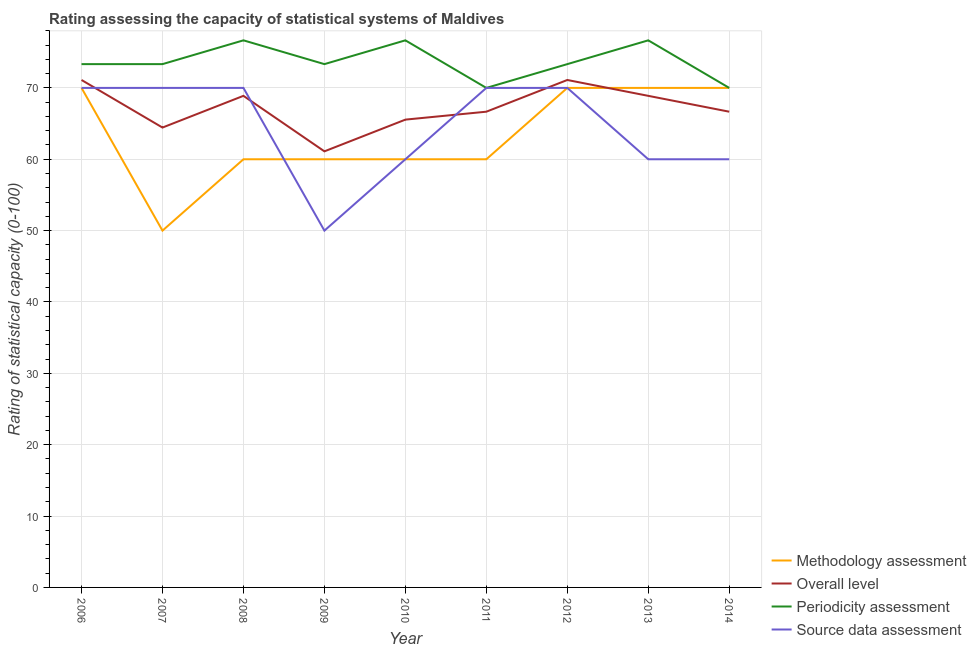How many different coloured lines are there?
Your response must be concise. 4. Is the number of lines equal to the number of legend labels?
Make the answer very short. Yes. Across all years, what is the maximum source data assessment rating?
Your response must be concise. 70. Across all years, what is the minimum overall level rating?
Your response must be concise. 61.11. In which year was the methodology assessment rating maximum?
Provide a succinct answer. 2006. What is the total source data assessment rating in the graph?
Offer a very short reply. 580. What is the difference between the periodicity assessment rating in 2009 and that in 2014?
Provide a succinct answer. 3.33. What is the average periodicity assessment rating per year?
Make the answer very short. 73.7. In the year 2009, what is the difference between the overall level rating and methodology assessment rating?
Offer a very short reply. 1.11. In how many years, is the overall level rating greater than 8?
Your response must be concise. 9. What is the ratio of the source data assessment rating in 2007 to that in 2011?
Keep it short and to the point. 1. Is the source data assessment rating in 2011 less than that in 2013?
Keep it short and to the point. No. Is the difference between the methodology assessment rating in 2006 and 2012 greater than the difference between the source data assessment rating in 2006 and 2012?
Offer a terse response. No. What is the difference between the highest and the second highest overall level rating?
Give a very brief answer. 0. What is the difference between the highest and the lowest periodicity assessment rating?
Offer a very short reply. 6.67. Is it the case that in every year, the sum of the methodology assessment rating and source data assessment rating is greater than the sum of periodicity assessment rating and overall level rating?
Give a very brief answer. No. Is it the case that in every year, the sum of the methodology assessment rating and overall level rating is greater than the periodicity assessment rating?
Ensure brevity in your answer.  Yes. Does the overall level rating monotonically increase over the years?
Your response must be concise. No. Is the overall level rating strictly less than the periodicity assessment rating over the years?
Give a very brief answer. Yes. How many years are there in the graph?
Your response must be concise. 9. What is the difference between two consecutive major ticks on the Y-axis?
Offer a terse response. 10. Does the graph contain any zero values?
Your answer should be compact. No. Does the graph contain grids?
Your response must be concise. Yes. Where does the legend appear in the graph?
Keep it short and to the point. Bottom right. How many legend labels are there?
Offer a very short reply. 4. How are the legend labels stacked?
Keep it short and to the point. Vertical. What is the title of the graph?
Provide a succinct answer. Rating assessing the capacity of statistical systems of Maldives. Does "International Development Association" appear as one of the legend labels in the graph?
Offer a very short reply. No. What is the label or title of the Y-axis?
Your answer should be compact. Rating of statistical capacity (0-100). What is the Rating of statistical capacity (0-100) of Methodology assessment in 2006?
Your response must be concise. 70. What is the Rating of statistical capacity (0-100) in Overall level in 2006?
Offer a very short reply. 71.11. What is the Rating of statistical capacity (0-100) of Periodicity assessment in 2006?
Offer a very short reply. 73.33. What is the Rating of statistical capacity (0-100) in Source data assessment in 2006?
Your answer should be very brief. 70. What is the Rating of statistical capacity (0-100) in Overall level in 2007?
Your answer should be very brief. 64.44. What is the Rating of statistical capacity (0-100) in Periodicity assessment in 2007?
Ensure brevity in your answer.  73.33. What is the Rating of statistical capacity (0-100) of Overall level in 2008?
Make the answer very short. 68.89. What is the Rating of statistical capacity (0-100) of Periodicity assessment in 2008?
Provide a short and direct response. 76.67. What is the Rating of statistical capacity (0-100) in Source data assessment in 2008?
Offer a very short reply. 70. What is the Rating of statistical capacity (0-100) of Overall level in 2009?
Provide a short and direct response. 61.11. What is the Rating of statistical capacity (0-100) in Periodicity assessment in 2009?
Your answer should be very brief. 73.33. What is the Rating of statistical capacity (0-100) in Methodology assessment in 2010?
Offer a very short reply. 60. What is the Rating of statistical capacity (0-100) of Overall level in 2010?
Keep it short and to the point. 65.56. What is the Rating of statistical capacity (0-100) of Periodicity assessment in 2010?
Offer a terse response. 76.67. What is the Rating of statistical capacity (0-100) in Source data assessment in 2010?
Your response must be concise. 60. What is the Rating of statistical capacity (0-100) of Overall level in 2011?
Keep it short and to the point. 66.67. What is the Rating of statistical capacity (0-100) of Source data assessment in 2011?
Your answer should be compact. 70. What is the Rating of statistical capacity (0-100) of Overall level in 2012?
Provide a succinct answer. 71.11. What is the Rating of statistical capacity (0-100) of Periodicity assessment in 2012?
Give a very brief answer. 73.33. What is the Rating of statistical capacity (0-100) in Source data assessment in 2012?
Your response must be concise. 70. What is the Rating of statistical capacity (0-100) of Overall level in 2013?
Provide a succinct answer. 68.89. What is the Rating of statistical capacity (0-100) in Periodicity assessment in 2013?
Provide a short and direct response. 76.67. What is the Rating of statistical capacity (0-100) in Methodology assessment in 2014?
Provide a succinct answer. 70. What is the Rating of statistical capacity (0-100) of Overall level in 2014?
Offer a very short reply. 66.67. What is the Rating of statistical capacity (0-100) in Periodicity assessment in 2014?
Your response must be concise. 70. Across all years, what is the maximum Rating of statistical capacity (0-100) of Methodology assessment?
Offer a very short reply. 70. Across all years, what is the maximum Rating of statistical capacity (0-100) in Overall level?
Offer a terse response. 71.11. Across all years, what is the maximum Rating of statistical capacity (0-100) of Periodicity assessment?
Keep it short and to the point. 76.67. Across all years, what is the maximum Rating of statistical capacity (0-100) of Source data assessment?
Provide a short and direct response. 70. Across all years, what is the minimum Rating of statistical capacity (0-100) in Overall level?
Provide a succinct answer. 61.11. What is the total Rating of statistical capacity (0-100) of Methodology assessment in the graph?
Provide a short and direct response. 570. What is the total Rating of statistical capacity (0-100) in Overall level in the graph?
Make the answer very short. 604.44. What is the total Rating of statistical capacity (0-100) of Periodicity assessment in the graph?
Make the answer very short. 663.33. What is the total Rating of statistical capacity (0-100) in Source data assessment in the graph?
Make the answer very short. 580. What is the difference between the Rating of statistical capacity (0-100) of Methodology assessment in 2006 and that in 2007?
Provide a succinct answer. 20. What is the difference between the Rating of statistical capacity (0-100) of Overall level in 2006 and that in 2007?
Give a very brief answer. 6.67. What is the difference between the Rating of statistical capacity (0-100) in Periodicity assessment in 2006 and that in 2007?
Your answer should be very brief. 0. What is the difference between the Rating of statistical capacity (0-100) of Methodology assessment in 2006 and that in 2008?
Your response must be concise. 10. What is the difference between the Rating of statistical capacity (0-100) of Overall level in 2006 and that in 2008?
Your answer should be very brief. 2.22. What is the difference between the Rating of statistical capacity (0-100) of Periodicity assessment in 2006 and that in 2008?
Offer a terse response. -3.33. What is the difference between the Rating of statistical capacity (0-100) in Source data assessment in 2006 and that in 2009?
Ensure brevity in your answer.  20. What is the difference between the Rating of statistical capacity (0-100) in Methodology assessment in 2006 and that in 2010?
Offer a very short reply. 10. What is the difference between the Rating of statistical capacity (0-100) in Overall level in 2006 and that in 2010?
Offer a very short reply. 5.56. What is the difference between the Rating of statistical capacity (0-100) of Periodicity assessment in 2006 and that in 2010?
Provide a short and direct response. -3.33. What is the difference between the Rating of statistical capacity (0-100) of Source data assessment in 2006 and that in 2010?
Make the answer very short. 10. What is the difference between the Rating of statistical capacity (0-100) of Overall level in 2006 and that in 2011?
Your answer should be very brief. 4.44. What is the difference between the Rating of statistical capacity (0-100) of Periodicity assessment in 2006 and that in 2011?
Offer a terse response. 3.33. What is the difference between the Rating of statistical capacity (0-100) in Source data assessment in 2006 and that in 2011?
Make the answer very short. 0. What is the difference between the Rating of statistical capacity (0-100) of Methodology assessment in 2006 and that in 2012?
Offer a terse response. 0. What is the difference between the Rating of statistical capacity (0-100) of Overall level in 2006 and that in 2012?
Your answer should be compact. 0. What is the difference between the Rating of statistical capacity (0-100) in Periodicity assessment in 2006 and that in 2012?
Provide a succinct answer. 0. What is the difference between the Rating of statistical capacity (0-100) of Methodology assessment in 2006 and that in 2013?
Offer a very short reply. 0. What is the difference between the Rating of statistical capacity (0-100) of Overall level in 2006 and that in 2013?
Provide a succinct answer. 2.22. What is the difference between the Rating of statistical capacity (0-100) in Overall level in 2006 and that in 2014?
Ensure brevity in your answer.  4.44. What is the difference between the Rating of statistical capacity (0-100) in Source data assessment in 2006 and that in 2014?
Offer a very short reply. 10. What is the difference between the Rating of statistical capacity (0-100) of Methodology assessment in 2007 and that in 2008?
Offer a terse response. -10. What is the difference between the Rating of statistical capacity (0-100) in Overall level in 2007 and that in 2008?
Offer a very short reply. -4.44. What is the difference between the Rating of statistical capacity (0-100) in Overall level in 2007 and that in 2009?
Your answer should be compact. 3.33. What is the difference between the Rating of statistical capacity (0-100) of Source data assessment in 2007 and that in 2009?
Offer a terse response. 20. What is the difference between the Rating of statistical capacity (0-100) of Overall level in 2007 and that in 2010?
Offer a terse response. -1.11. What is the difference between the Rating of statistical capacity (0-100) in Periodicity assessment in 2007 and that in 2010?
Make the answer very short. -3.33. What is the difference between the Rating of statistical capacity (0-100) in Overall level in 2007 and that in 2011?
Provide a succinct answer. -2.22. What is the difference between the Rating of statistical capacity (0-100) in Periodicity assessment in 2007 and that in 2011?
Make the answer very short. 3.33. What is the difference between the Rating of statistical capacity (0-100) in Overall level in 2007 and that in 2012?
Offer a very short reply. -6.67. What is the difference between the Rating of statistical capacity (0-100) in Methodology assessment in 2007 and that in 2013?
Make the answer very short. -20. What is the difference between the Rating of statistical capacity (0-100) in Overall level in 2007 and that in 2013?
Give a very brief answer. -4.44. What is the difference between the Rating of statistical capacity (0-100) in Periodicity assessment in 2007 and that in 2013?
Ensure brevity in your answer.  -3.33. What is the difference between the Rating of statistical capacity (0-100) in Overall level in 2007 and that in 2014?
Your answer should be very brief. -2.22. What is the difference between the Rating of statistical capacity (0-100) in Periodicity assessment in 2007 and that in 2014?
Provide a short and direct response. 3.33. What is the difference between the Rating of statistical capacity (0-100) in Overall level in 2008 and that in 2009?
Offer a terse response. 7.78. What is the difference between the Rating of statistical capacity (0-100) of Periodicity assessment in 2008 and that in 2009?
Provide a succinct answer. 3.33. What is the difference between the Rating of statistical capacity (0-100) of Source data assessment in 2008 and that in 2009?
Offer a terse response. 20. What is the difference between the Rating of statistical capacity (0-100) in Overall level in 2008 and that in 2010?
Offer a terse response. 3.33. What is the difference between the Rating of statistical capacity (0-100) in Methodology assessment in 2008 and that in 2011?
Your answer should be very brief. 0. What is the difference between the Rating of statistical capacity (0-100) of Overall level in 2008 and that in 2011?
Your answer should be compact. 2.22. What is the difference between the Rating of statistical capacity (0-100) in Periodicity assessment in 2008 and that in 2011?
Keep it short and to the point. 6.67. What is the difference between the Rating of statistical capacity (0-100) of Source data assessment in 2008 and that in 2011?
Provide a short and direct response. 0. What is the difference between the Rating of statistical capacity (0-100) in Overall level in 2008 and that in 2012?
Offer a terse response. -2.22. What is the difference between the Rating of statistical capacity (0-100) of Periodicity assessment in 2008 and that in 2012?
Provide a succinct answer. 3.33. What is the difference between the Rating of statistical capacity (0-100) in Methodology assessment in 2008 and that in 2013?
Offer a terse response. -10. What is the difference between the Rating of statistical capacity (0-100) in Source data assessment in 2008 and that in 2013?
Your response must be concise. 10. What is the difference between the Rating of statistical capacity (0-100) of Overall level in 2008 and that in 2014?
Offer a terse response. 2.22. What is the difference between the Rating of statistical capacity (0-100) in Source data assessment in 2008 and that in 2014?
Your answer should be very brief. 10. What is the difference between the Rating of statistical capacity (0-100) of Methodology assessment in 2009 and that in 2010?
Keep it short and to the point. 0. What is the difference between the Rating of statistical capacity (0-100) of Overall level in 2009 and that in 2010?
Provide a succinct answer. -4.44. What is the difference between the Rating of statistical capacity (0-100) in Source data assessment in 2009 and that in 2010?
Your answer should be very brief. -10. What is the difference between the Rating of statistical capacity (0-100) of Overall level in 2009 and that in 2011?
Offer a very short reply. -5.56. What is the difference between the Rating of statistical capacity (0-100) in Periodicity assessment in 2009 and that in 2011?
Your answer should be compact. 3.33. What is the difference between the Rating of statistical capacity (0-100) in Source data assessment in 2009 and that in 2011?
Offer a terse response. -20. What is the difference between the Rating of statistical capacity (0-100) in Methodology assessment in 2009 and that in 2012?
Ensure brevity in your answer.  -10. What is the difference between the Rating of statistical capacity (0-100) of Overall level in 2009 and that in 2012?
Provide a short and direct response. -10. What is the difference between the Rating of statistical capacity (0-100) in Source data assessment in 2009 and that in 2012?
Make the answer very short. -20. What is the difference between the Rating of statistical capacity (0-100) in Methodology assessment in 2009 and that in 2013?
Your answer should be compact. -10. What is the difference between the Rating of statistical capacity (0-100) in Overall level in 2009 and that in 2013?
Ensure brevity in your answer.  -7.78. What is the difference between the Rating of statistical capacity (0-100) in Periodicity assessment in 2009 and that in 2013?
Your response must be concise. -3.33. What is the difference between the Rating of statistical capacity (0-100) of Methodology assessment in 2009 and that in 2014?
Your response must be concise. -10. What is the difference between the Rating of statistical capacity (0-100) in Overall level in 2009 and that in 2014?
Your response must be concise. -5.56. What is the difference between the Rating of statistical capacity (0-100) in Periodicity assessment in 2009 and that in 2014?
Offer a very short reply. 3.33. What is the difference between the Rating of statistical capacity (0-100) of Source data assessment in 2009 and that in 2014?
Provide a short and direct response. -10. What is the difference between the Rating of statistical capacity (0-100) of Methodology assessment in 2010 and that in 2011?
Your response must be concise. 0. What is the difference between the Rating of statistical capacity (0-100) of Overall level in 2010 and that in 2011?
Make the answer very short. -1.11. What is the difference between the Rating of statistical capacity (0-100) in Overall level in 2010 and that in 2012?
Offer a terse response. -5.56. What is the difference between the Rating of statistical capacity (0-100) of Methodology assessment in 2010 and that in 2013?
Offer a very short reply. -10. What is the difference between the Rating of statistical capacity (0-100) of Overall level in 2010 and that in 2014?
Provide a short and direct response. -1.11. What is the difference between the Rating of statistical capacity (0-100) of Periodicity assessment in 2010 and that in 2014?
Provide a short and direct response. 6.67. What is the difference between the Rating of statistical capacity (0-100) of Methodology assessment in 2011 and that in 2012?
Make the answer very short. -10. What is the difference between the Rating of statistical capacity (0-100) of Overall level in 2011 and that in 2012?
Make the answer very short. -4.44. What is the difference between the Rating of statistical capacity (0-100) of Periodicity assessment in 2011 and that in 2012?
Give a very brief answer. -3.33. What is the difference between the Rating of statistical capacity (0-100) of Overall level in 2011 and that in 2013?
Offer a very short reply. -2.22. What is the difference between the Rating of statistical capacity (0-100) in Periodicity assessment in 2011 and that in 2013?
Provide a short and direct response. -6.67. What is the difference between the Rating of statistical capacity (0-100) in Overall level in 2011 and that in 2014?
Your response must be concise. 0. What is the difference between the Rating of statistical capacity (0-100) in Source data assessment in 2011 and that in 2014?
Offer a terse response. 10. What is the difference between the Rating of statistical capacity (0-100) of Overall level in 2012 and that in 2013?
Your response must be concise. 2.22. What is the difference between the Rating of statistical capacity (0-100) in Periodicity assessment in 2012 and that in 2013?
Keep it short and to the point. -3.33. What is the difference between the Rating of statistical capacity (0-100) of Overall level in 2012 and that in 2014?
Keep it short and to the point. 4.44. What is the difference between the Rating of statistical capacity (0-100) of Periodicity assessment in 2012 and that in 2014?
Offer a terse response. 3.33. What is the difference between the Rating of statistical capacity (0-100) of Methodology assessment in 2013 and that in 2014?
Give a very brief answer. 0. What is the difference between the Rating of statistical capacity (0-100) of Overall level in 2013 and that in 2014?
Keep it short and to the point. 2.22. What is the difference between the Rating of statistical capacity (0-100) in Periodicity assessment in 2013 and that in 2014?
Your answer should be compact. 6.67. What is the difference between the Rating of statistical capacity (0-100) of Source data assessment in 2013 and that in 2014?
Your answer should be compact. 0. What is the difference between the Rating of statistical capacity (0-100) of Methodology assessment in 2006 and the Rating of statistical capacity (0-100) of Overall level in 2007?
Offer a very short reply. 5.56. What is the difference between the Rating of statistical capacity (0-100) in Overall level in 2006 and the Rating of statistical capacity (0-100) in Periodicity assessment in 2007?
Offer a terse response. -2.22. What is the difference between the Rating of statistical capacity (0-100) in Periodicity assessment in 2006 and the Rating of statistical capacity (0-100) in Source data assessment in 2007?
Keep it short and to the point. 3.33. What is the difference between the Rating of statistical capacity (0-100) in Methodology assessment in 2006 and the Rating of statistical capacity (0-100) in Periodicity assessment in 2008?
Provide a succinct answer. -6.67. What is the difference between the Rating of statistical capacity (0-100) in Methodology assessment in 2006 and the Rating of statistical capacity (0-100) in Source data assessment in 2008?
Ensure brevity in your answer.  0. What is the difference between the Rating of statistical capacity (0-100) in Overall level in 2006 and the Rating of statistical capacity (0-100) in Periodicity assessment in 2008?
Give a very brief answer. -5.56. What is the difference between the Rating of statistical capacity (0-100) in Methodology assessment in 2006 and the Rating of statistical capacity (0-100) in Overall level in 2009?
Provide a short and direct response. 8.89. What is the difference between the Rating of statistical capacity (0-100) of Methodology assessment in 2006 and the Rating of statistical capacity (0-100) of Periodicity assessment in 2009?
Provide a short and direct response. -3.33. What is the difference between the Rating of statistical capacity (0-100) of Overall level in 2006 and the Rating of statistical capacity (0-100) of Periodicity assessment in 2009?
Your response must be concise. -2.22. What is the difference between the Rating of statistical capacity (0-100) in Overall level in 2006 and the Rating of statistical capacity (0-100) in Source data assessment in 2009?
Keep it short and to the point. 21.11. What is the difference between the Rating of statistical capacity (0-100) in Periodicity assessment in 2006 and the Rating of statistical capacity (0-100) in Source data assessment in 2009?
Ensure brevity in your answer.  23.33. What is the difference between the Rating of statistical capacity (0-100) in Methodology assessment in 2006 and the Rating of statistical capacity (0-100) in Overall level in 2010?
Give a very brief answer. 4.44. What is the difference between the Rating of statistical capacity (0-100) in Methodology assessment in 2006 and the Rating of statistical capacity (0-100) in Periodicity assessment in 2010?
Offer a terse response. -6.67. What is the difference between the Rating of statistical capacity (0-100) of Overall level in 2006 and the Rating of statistical capacity (0-100) of Periodicity assessment in 2010?
Your answer should be very brief. -5.56. What is the difference between the Rating of statistical capacity (0-100) of Overall level in 2006 and the Rating of statistical capacity (0-100) of Source data assessment in 2010?
Your answer should be very brief. 11.11. What is the difference between the Rating of statistical capacity (0-100) in Periodicity assessment in 2006 and the Rating of statistical capacity (0-100) in Source data assessment in 2010?
Provide a short and direct response. 13.33. What is the difference between the Rating of statistical capacity (0-100) of Methodology assessment in 2006 and the Rating of statistical capacity (0-100) of Periodicity assessment in 2011?
Offer a terse response. 0. What is the difference between the Rating of statistical capacity (0-100) in Methodology assessment in 2006 and the Rating of statistical capacity (0-100) in Source data assessment in 2011?
Your answer should be compact. 0. What is the difference between the Rating of statistical capacity (0-100) of Overall level in 2006 and the Rating of statistical capacity (0-100) of Periodicity assessment in 2011?
Your response must be concise. 1.11. What is the difference between the Rating of statistical capacity (0-100) in Methodology assessment in 2006 and the Rating of statistical capacity (0-100) in Overall level in 2012?
Offer a very short reply. -1.11. What is the difference between the Rating of statistical capacity (0-100) of Methodology assessment in 2006 and the Rating of statistical capacity (0-100) of Periodicity assessment in 2012?
Ensure brevity in your answer.  -3.33. What is the difference between the Rating of statistical capacity (0-100) in Overall level in 2006 and the Rating of statistical capacity (0-100) in Periodicity assessment in 2012?
Keep it short and to the point. -2.22. What is the difference between the Rating of statistical capacity (0-100) in Periodicity assessment in 2006 and the Rating of statistical capacity (0-100) in Source data assessment in 2012?
Keep it short and to the point. 3.33. What is the difference between the Rating of statistical capacity (0-100) of Methodology assessment in 2006 and the Rating of statistical capacity (0-100) of Overall level in 2013?
Provide a succinct answer. 1.11. What is the difference between the Rating of statistical capacity (0-100) of Methodology assessment in 2006 and the Rating of statistical capacity (0-100) of Periodicity assessment in 2013?
Give a very brief answer. -6.67. What is the difference between the Rating of statistical capacity (0-100) of Overall level in 2006 and the Rating of statistical capacity (0-100) of Periodicity assessment in 2013?
Ensure brevity in your answer.  -5.56. What is the difference between the Rating of statistical capacity (0-100) of Overall level in 2006 and the Rating of statistical capacity (0-100) of Source data assessment in 2013?
Offer a terse response. 11.11. What is the difference between the Rating of statistical capacity (0-100) in Periodicity assessment in 2006 and the Rating of statistical capacity (0-100) in Source data assessment in 2013?
Give a very brief answer. 13.33. What is the difference between the Rating of statistical capacity (0-100) of Methodology assessment in 2006 and the Rating of statistical capacity (0-100) of Overall level in 2014?
Ensure brevity in your answer.  3.33. What is the difference between the Rating of statistical capacity (0-100) in Methodology assessment in 2006 and the Rating of statistical capacity (0-100) in Periodicity assessment in 2014?
Offer a terse response. 0. What is the difference between the Rating of statistical capacity (0-100) of Methodology assessment in 2006 and the Rating of statistical capacity (0-100) of Source data assessment in 2014?
Your response must be concise. 10. What is the difference between the Rating of statistical capacity (0-100) in Overall level in 2006 and the Rating of statistical capacity (0-100) in Source data assessment in 2014?
Your response must be concise. 11.11. What is the difference between the Rating of statistical capacity (0-100) of Periodicity assessment in 2006 and the Rating of statistical capacity (0-100) of Source data assessment in 2014?
Make the answer very short. 13.33. What is the difference between the Rating of statistical capacity (0-100) of Methodology assessment in 2007 and the Rating of statistical capacity (0-100) of Overall level in 2008?
Ensure brevity in your answer.  -18.89. What is the difference between the Rating of statistical capacity (0-100) in Methodology assessment in 2007 and the Rating of statistical capacity (0-100) in Periodicity assessment in 2008?
Offer a very short reply. -26.67. What is the difference between the Rating of statistical capacity (0-100) of Methodology assessment in 2007 and the Rating of statistical capacity (0-100) of Source data assessment in 2008?
Provide a succinct answer. -20. What is the difference between the Rating of statistical capacity (0-100) in Overall level in 2007 and the Rating of statistical capacity (0-100) in Periodicity assessment in 2008?
Offer a very short reply. -12.22. What is the difference between the Rating of statistical capacity (0-100) in Overall level in 2007 and the Rating of statistical capacity (0-100) in Source data assessment in 2008?
Give a very brief answer. -5.56. What is the difference between the Rating of statistical capacity (0-100) in Methodology assessment in 2007 and the Rating of statistical capacity (0-100) in Overall level in 2009?
Your response must be concise. -11.11. What is the difference between the Rating of statistical capacity (0-100) in Methodology assessment in 2007 and the Rating of statistical capacity (0-100) in Periodicity assessment in 2009?
Offer a terse response. -23.33. What is the difference between the Rating of statistical capacity (0-100) of Overall level in 2007 and the Rating of statistical capacity (0-100) of Periodicity assessment in 2009?
Your answer should be compact. -8.89. What is the difference between the Rating of statistical capacity (0-100) in Overall level in 2007 and the Rating of statistical capacity (0-100) in Source data assessment in 2009?
Your answer should be very brief. 14.44. What is the difference between the Rating of statistical capacity (0-100) of Periodicity assessment in 2007 and the Rating of statistical capacity (0-100) of Source data assessment in 2009?
Your response must be concise. 23.33. What is the difference between the Rating of statistical capacity (0-100) of Methodology assessment in 2007 and the Rating of statistical capacity (0-100) of Overall level in 2010?
Your response must be concise. -15.56. What is the difference between the Rating of statistical capacity (0-100) of Methodology assessment in 2007 and the Rating of statistical capacity (0-100) of Periodicity assessment in 2010?
Make the answer very short. -26.67. What is the difference between the Rating of statistical capacity (0-100) in Overall level in 2007 and the Rating of statistical capacity (0-100) in Periodicity assessment in 2010?
Offer a very short reply. -12.22. What is the difference between the Rating of statistical capacity (0-100) in Overall level in 2007 and the Rating of statistical capacity (0-100) in Source data assessment in 2010?
Offer a terse response. 4.44. What is the difference between the Rating of statistical capacity (0-100) in Periodicity assessment in 2007 and the Rating of statistical capacity (0-100) in Source data assessment in 2010?
Ensure brevity in your answer.  13.33. What is the difference between the Rating of statistical capacity (0-100) in Methodology assessment in 2007 and the Rating of statistical capacity (0-100) in Overall level in 2011?
Your answer should be compact. -16.67. What is the difference between the Rating of statistical capacity (0-100) in Methodology assessment in 2007 and the Rating of statistical capacity (0-100) in Periodicity assessment in 2011?
Ensure brevity in your answer.  -20. What is the difference between the Rating of statistical capacity (0-100) in Overall level in 2007 and the Rating of statistical capacity (0-100) in Periodicity assessment in 2011?
Give a very brief answer. -5.56. What is the difference between the Rating of statistical capacity (0-100) of Overall level in 2007 and the Rating of statistical capacity (0-100) of Source data assessment in 2011?
Make the answer very short. -5.56. What is the difference between the Rating of statistical capacity (0-100) in Periodicity assessment in 2007 and the Rating of statistical capacity (0-100) in Source data assessment in 2011?
Keep it short and to the point. 3.33. What is the difference between the Rating of statistical capacity (0-100) of Methodology assessment in 2007 and the Rating of statistical capacity (0-100) of Overall level in 2012?
Give a very brief answer. -21.11. What is the difference between the Rating of statistical capacity (0-100) of Methodology assessment in 2007 and the Rating of statistical capacity (0-100) of Periodicity assessment in 2012?
Provide a succinct answer. -23.33. What is the difference between the Rating of statistical capacity (0-100) in Overall level in 2007 and the Rating of statistical capacity (0-100) in Periodicity assessment in 2012?
Keep it short and to the point. -8.89. What is the difference between the Rating of statistical capacity (0-100) in Overall level in 2007 and the Rating of statistical capacity (0-100) in Source data assessment in 2012?
Offer a terse response. -5.56. What is the difference between the Rating of statistical capacity (0-100) in Methodology assessment in 2007 and the Rating of statistical capacity (0-100) in Overall level in 2013?
Make the answer very short. -18.89. What is the difference between the Rating of statistical capacity (0-100) of Methodology assessment in 2007 and the Rating of statistical capacity (0-100) of Periodicity assessment in 2013?
Provide a succinct answer. -26.67. What is the difference between the Rating of statistical capacity (0-100) in Overall level in 2007 and the Rating of statistical capacity (0-100) in Periodicity assessment in 2013?
Your answer should be very brief. -12.22. What is the difference between the Rating of statistical capacity (0-100) of Overall level in 2007 and the Rating of statistical capacity (0-100) of Source data assessment in 2013?
Your answer should be compact. 4.44. What is the difference between the Rating of statistical capacity (0-100) of Periodicity assessment in 2007 and the Rating of statistical capacity (0-100) of Source data assessment in 2013?
Ensure brevity in your answer.  13.33. What is the difference between the Rating of statistical capacity (0-100) of Methodology assessment in 2007 and the Rating of statistical capacity (0-100) of Overall level in 2014?
Make the answer very short. -16.67. What is the difference between the Rating of statistical capacity (0-100) in Methodology assessment in 2007 and the Rating of statistical capacity (0-100) in Source data assessment in 2014?
Give a very brief answer. -10. What is the difference between the Rating of statistical capacity (0-100) in Overall level in 2007 and the Rating of statistical capacity (0-100) in Periodicity assessment in 2014?
Your answer should be very brief. -5.56. What is the difference between the Rating of statistical capacity (0-100) of Overall level in 2007 and the Rating of statistical capacity (0-100) of Source data assessment in 2014?
Offer a very short reply. 4.44. What is the difference between the Rating of statistical capacity (0-100) in Periodicity assessment in 2007 and the Rating of statistical capacity (0-100) in Source data assessment in 2014?
Make the answer very short. 13.33. What is the difference between the Rating of statistical capacity (0-100) of Methodology assessment in 2008 and the Rating of statistical capacity (0-100) of Overall level in 2009?
Provide a short and direct response. -1.11. What is the difference between the Rating of statistical capacity (0-100) in Methodology assessment in 2008 and the Rating of statistical capacity (0-100) in Periodicity assessment in 2009?
Give a very brief answer. -13.33. What is the difference between the Rating of statistical capacity (0-100) in Overall level in 2008 and the Rating of statistical capacity (0-100) in Periodicity assessment in 2009?
Give a very brief answer. -4.44. What is the difference between the Rating of statistical capacity (0-100) in Overall level in 2008 and the Rating of statistical capacity (0-100) in Source data assessment in 2009?
Offer a terse response. 18.89. What is the difference between the Rating of statistical capacity (0-100) in Periodicity assessment in 2008 and the Rating of statistical capacity (0-100) in Source data assessment in 2009?
Provide a short and direct response. 26.67. What is the difference between the Rating of statistical capacity (0-100) in Methodology assessment in 2008 and the Rating of statistical capacity (0-100) in Overall level in 2010?
Give a very brief answer. -5.56. What is the difference between the Rating of statistical capacity (0-100) of Methodology assessment in 2008 and the Rating of statistical capacity (0-100) of Periodicity assessment in 2010?
Keep it short and to the point. -16.67. What is the difference between the Rating of statistical capacity (0-100) in Methodology assessment in 2008 and the Rating of statistical capacity (0-100) in Source data assessment in 2010?
Give a very brief answer. 0. What is the difference between the Rating of statistical capacity (0-100) of Overall level in 2008 and the Rating of statistical capacity (0-100) of Periodicity assessment in 2010?
Your answer should be compact. -7.78. What is the difference between the Rating of statistical capacity (0-100) in Overall level in 2008 and the Rating of statistical capacity (0-100) in Source data assessment in 2010?
Ensure brevity in your answer.  8.89. What is the difference between the Rating of statistical capacity (0-100) in Periodicity assessment in 2008 and the Rating of statistical capacity (0-100) in Source data assessment in 2010?
Keep it short and to the point. 16.67. What is the difference between the Rating of statistical capacity (0-100) in Methodology assessment in 2008 and the Rating of statistical capacity (0-100) in Overall level in 2011?
Offer a terse response. -6.67. What is the difference between the Rating of statistical capacity (0-100) in Methodology assessment in 2008 and the Rating of statistical capacity (0-100) in Source data assessment in 2011?
Offer a very short reply. -10. What is the difference between the Rating of statistical capacity (0-100) of Overall level in 2008 and the Rating of statistical capacity (0-100) of Periodicity assessment in 2011?
Offer a very short reply. -1.11. What is the difference between the Rating of statistical capacity (0-100) of Overall level in 2008 and the Rating of statistical capacity (0-100) of Source data assessment in 2011?
Your response must be concise. -1.11. What is the difference between the Rating of statistical capacity (0-100) of Methodology assessment in 2008 and the Rating of statistical capacity (0-100) of Overall level in 2012?
Make the answer very short. -11.11. What is the difference between the Rating of statistical capacity (0-100) of Methodology assessment in 2008 and the Rating of statistical capacity (0-100) of Periodicity assessment in 2012?
Provide a short and direct response. -13.33. What is the difference between the Rating of statistical capacity (0-100) of Methodology assessment in 2008 and the Rating of statistical capacity (0-100) of Source data assessment in 2012?
Offer a terse response. -10. What is the difference between the Rating of statistical capacity (0-100) of Overall level in 2008 and the Rating of statistical capacity (0-100) of Periodicity assessment in 2012?
Provide a succinct answer. -4.44. What is the difference between the Rating of statistical capacity (0-100) of Overall level in 2008 and the Rating of statistical capacity (0-100) of Source data assessment in 2012?
Your answer should be very brief. -1.11. What is the difference between the Rating of statistical capacity (0-100) in Periodicity assessment in 2008 and the Rating of statistical capacity (0-100) in Source data assessment in 2012?
Provide a short and direct response. 6.67. What is the difference between the Rating of statistical capacity (0-100) in Methodology assessment in 2008 and the Rating of statistical capacity (0-100) in Overall level in 2013?
Ensure brevity in your answer.  -8.89. What is the difference between the Rating of statistical capacity (0-100) of Methodology assessment in 2008 and the Rating of statistical capacity (0-100) of Periodicity assessment in 2013?
Your response must be concise. -16.67. What is the difference between the Rating of statistical capacity (0-100) of Methodology assessment in 2008 and the Rating of statistical capacity (0-100) of Source data assessment in 2013?
Your answer should be very brief. 0. What is the difference between the Rating of statistical capacity (0-100) in Overall level in 2008 and the Rating of statistical capacity (0-100) in Periodicity assessment in 2013?
Ensure brevity in your answer.  -7.78. What is the difference between the Rating of statistical capacity (0-100) of Overall level in 2008 and the Rating of statistical capacity (0-100) of Source data assessment in 2013?
Your answer should be very brief. 8.89. What is the difference between the Rating of statistical capacity (0-100) in Periodicity assessment in 2008 and the Rating of statistical capacity (0-100) in Source data assessment in 2013?
Make the answer very short. 16.67. What is the difference between the Rating of statistical capacity (0-100) of Methodology assessment in 2008 and the Rating of statistical capacity (0-100) of Overall level in 2014?
Ensure brevity in your answer.  -6.67. What is the difference between the Rating of statistical capacity (0-100) in Overall level in 2008 and the Rating of statistical capacity (0-100) in Periodicity assessment in 2014?
Offer a very short reply. -1.11. What is the difference between the Rating of statistical capacity (0-100) of Overall level in 2008 and the Rating of statistical capacity (0-100) of Source data assessment in 2014?
Ensure brevity in your answer.  8.89. What is the difference between the Rating of statistical capacity (0-100) of Periodicity assessment in 2008 and the Rating of statistical capacity (0-100) of Source data assessment in 2014?
Your response must be concise. 16.67. What is the difference between the Rating of statistical capacity (0-100) of Methodology assessment in 2009 and the Rating of statistical capacity (0-100) of Overall level in 2010?
Give a very brief answer. -5.56. What is the difference between the Rating of statistical capacity (0-100) of Methodology assessment in 2009 and the Rating of statistical capacity (0-100) of Periodicity assessment in 2010?
Offer a very short reply. -16.67. What is the difference between the Rating of statistical capacity (0-100) in Overall level in 2009 and the Rating of statistical capacity (0-100) in Periodicity assessment in 2010?
Provide a short and direct response. -15.56. What is the difference between the Rating of statistical capacity (0-100) of Overall level in 2009 and the Rating of statistical capacity (0-100) of Source data assessment in 2010?
Your answer should be compact. 1.11. What is the difference between the Rating of statistical capacity (0-100) in Periodicity assessment in 2009 and the Rating of statistical capacity (0-100) in Source data assessment in 2010?
Keep it short and to the point. 13.33. What is the difference between the Rating of statistical capacity (0-100) of Methodology assessment in 2009 and the Rating of statistical capacity (0-100) of Overall level in 2011?
Keep it short and to the point. -6.67. What is the difference between the Rating of statistical capacity (0-100) of Methodology assessment in 2009 and the Rating of statistical capacity (0-100) of Periodicity assessment in 2011?
Provide a succinct answer. -10. What is the difference between the Rating of statistical capacity (0-100) of Overall level in 2009 and the Rating of statistical capacity (0-100) of Periodicity assessment in 2011?
Provide a short and direct response. -8.89. What is the difference between the Rating of statistical capacity (0-100) of Overall level in 2009 and the Rating of statistical capacity (0-100) of Source data assessment in 2011?
Offer a very short reply. -8.89. What is the difference between the Rating of statistical capacity (0-100) of Periodicity assessment in 2009 and the Rating of statistical capacity (0-100) of Source data assessment in 2011?
Your response must be concise. 3.33. What is the difference between the Rating of statistical capacity (0-100) in Methodology assessment in 2009 and the Rating of statistical capacity (0-100) in Overall level in 2012?
Provide a succinct answer. -11.11. What is the difference between the Rating of statistical capacity (0-100) in Methodology assessment in 2009 and the Rating of statistical capacity (0-100) in Periodicity assessment in 2012?
Your answer should be very brief. -13.33. What is the difference between the Rating of statistical capacity (0-100) in Overall level in 2009 and the Rating of statistical capacity (0-100) in Periodicity assessment in 2012?
Your answer should be very brief. -12.22. What is the difference between the Rating of statistical capacity (0-100) in Overall level in 2009 and the Rating of statistical capacity (0-100) in Source data assessment in 2012?
Your response must be concise. -8.89. What is the difference between the Rating of statistical capacity (0-100) of Methodology assessment in 2009 and the Rating of statistical capacity (0-100) of Overall level in 2013?
Your answer should be compact. -8.89. What is the difference between the Rating of statistical capacity (0-100) of Methodology assessment in 2009 and the Rating of statistical capacity (0-100) of Periodicity assessment in 2013?
Provide a succinct answer. -16.67. What is the difference between the Rating of statistical capacity (0-100) in Overall level in 2009 and the Rating of statistical capacity (0-100) in Periodicity assessment in 2013?
Provide a succinct answer. -15.56. What is the difference between the Rating of statistical capacity (0-100) in Periodicity assessment in 2009 and the Rating of statistical capacity (0-100) in Source data assessment in 2013?
Your response must be concise. 13.33. What is the difference between the Rating of statistical capacity (0-100) in Methodology assessment in 2009 and the Rating of statistical capacity (0-100) in Overall level in 2014?
Offer a terse response. -6.67. What is the difference between the Rating of statistical capacity (0-100) in Methodology assessment in 2009 and the Rating of statistical capacity (0-100) in Periodicity assessment in 2014?
Make the answer very short. -10. What is the difference between the Rating of statistical capacity (0-100) of Methodology assessment in 2009 and the Rating of statistical capacity (0-100) of Source data assessment in 2014?
Your answer should be very brief. 0. What is the difference between the Rating of statistical capacity (0-100) in Overall level in 2009 and the Rating of statistical capacity (0-100) in Periodicity assessment in 2014?
Offer a terse response. -8.89. What is the difference between the Rating of statistical capacity (0-100) of Periodicity assessment in 2009 and the Rating of statistical capacity (0-100) of Source data assessment in 2014?
Offer a very short reply. 13.33. What is the difference between the Rating of statistical capacity (0-100) of Methodology assessment in 2010 and the Rating of statistical capacity (0-100) of Overall level in 2011?
Give a very brief answer. -6.67. What is the difference between the Rating of statistical capacity (0-100) in Methodology assessment in 2010 and the Rating of statistical capacity (0-100) in Periodicity assessment in 2011?
Offer a very short reply. -10. What is the difference between the Rating of statistical capacity (0-100) in Methodology assessment in 2010 and the Rating of statistical capacity (0-100) in Source data assessment in 2011?
Give a very brief answer. -10. What is the difference between the Rating of statistical capacity (0-100) of Overall level in 2010 and the Rating of statistical capacity (0-100) of Periodicity assessment in 2011?
Give a very brief answer. -4.44. What is the difference between the Rating of statistical capacity (0-100) of Overall level in 2010 and the Rating of statistical capacity (0-100) of Source data assessment in 2011?
Ensure brevity in your answer.  -4.44. What is the difference between the Rating of statistical capacity (0-100) of Periodicity assessment in 2010 and the Rating of statistical capacity (0-100) of Source data assessment in 2011?
Your answer should be very brief. 6.67. What is the difference between the Rating of statistical capacity (0-100) in Methodology assessment in 2010 and the Rating of statistical capacity (0-100) in Overall level in 2012?
Make the answer very short. -11.11. What is the difference between the Rating of statistical capacity (0-100) in Methodology assessment in 2010 and the Rating of statistical capacity (0-100) in Periodicity assessment in 2012?
Ensure brevity in your answer.  -13.33. What is the difference between the Rating of statistical capacity (0-100) of Overall level in 2010 and the Rating of statistical capacity (0-100) of Periodicity assessment in 2012?
Your answer should be very brief. -7.78. What is the difference between the Rating of statistical capacity (0-100) of Overall level in 2010 and the Rating of statistical capacity (0-100) of Source data assessment in 2012?
Ensure brevity in your answer.  -4.44. What is the difference between the Rating of statistical capacity (0-100) in Methodology assessment in 2010 and the Rating of statistical capacity (0-100) in Overall level in 2013?
Keep it short and to the point. -8.89. What is the difference between the Rating of statistical capacity (0-100) in Methodology assessment in 2010 and the Rating of statistical capacity (0-100) in Periodicity assessment in 2013?
Provide a succinct answer. -16.67. What is the difference between the Rating of statistical capacity (0-100) in Methodology assessment in 2010 and the Rating of statistical capacity (0-100) in Source data assessment in 2013?
Your answer should be compact. 0. What is the difference between the Rating of statistical capacity (0-100) in Overall level in 2010 and the Rating of statistical capacity (0-100) in Periodicity assessment in 2013?
Make the answer very short. -11.11. What is the difference between the Rating of statistical capacity (0-100) of Overall level in 2010 and the Rating of statistical capacity (0-100) of Source data assessment in 2013?
Offer a terse response. 5.56. What is the difference between the Rating of statistical capacity (0-100) in Periodicity assessment in 2010 and the Rating of statistical capacity (0-100) in Source data assessment in 2013?
Keep it short and to the point. 16.67. What is the difference between the Rating of statistical capacity (0-100) of Methodology assessment in 2010 and the Rating of statistical capacity (0-100) of Overall level in 2014?
Your answer should be very brief. -6.67. What is the difference between the Rating of statistical capacity (0-100) of Methodology assessment in 2010 and the Rating of statistical capacity (0-100) of Periodicity assessment in 2014?
Offer a terse response. -10. What is the difference between the Rating of statistical capacity (0-100) of Overall level in 2010 and the Rating of statistical capacity (0-100) of Periodicity assessment in 2014?
Give a very brief answer. -4.44. What is the difference between the Rating of statistical capacity (0-100) of Overall level in 2010 and the Rating of statistical capacity (0-100) of Source data assessment in 2014?
Provide a succinct answer. 5.56. What is the difference between the Rating of statistical capacity (0-100) of Periodicity assessment in 2010 and the Rating of statistical capacity (0-100) of Source data assessment in 2014?
Make the answer very short. 16.67. What is the difference between the Rating of statistical capacity (0-100) of Methodology assessment in 2011 and the Rating of statistical capacity (0-100) of Overall level in 2012?
Offer a very short reply. -11.11. What is the difference between the Rating of statistical capacity (0-100) in Methodology assessment in 2011 and the Rating of statistical capacity (0-100) in Periodicity assessment in 2012?
Offer a terse response. -13.33. What is the difference between the Rating of statistical capacity (0-100) in Methodology assessment in 2011 and the Rating of statistical capacity (0-100) in Source data assessment in 2012?
Provide a short and direct response. -10. What is the difference between the Rating of statistical capacity (0-100) of Overall level in 2011 and the Rating of statistical capacity (0-100) of Periodicity assessment in 2012?
Provide a succinct answer. -6.67. What is the difference between the Rating of statistical capacity (0-100) in Overall level in 2011 and the Rating of statistical capacity (0-100) in Source data assessment in 2012?
Make the answer very short. -3.33. What is the difference between the Rating of statistical capacity (0-100) in Periodicity assessment in 2011 and the Rating of statistical capacity (0-100) in Source data assessment in 2012?
Offer a very short reply. 0. What is the difference between the Rating of statistical capacity (0-100) of Methodology assessment in 2011 and the Rating of statistical capacity (0-100) of Overall level in 2013?
Your answer should be very brief. -8.89. What is the difference between the Rating of statistical capacity (0-100) in Methodology assessment in 2011 and the Rating of statistical capacity (0-100) in Periodicity assessment in 2013?
Ensure brevity in your answer.  -16.67. What is the difference between the Rating of statistical capacity (0-100) of Overall level in 2011 and the Rating of statistical capacity (0-100) of Source data assessment in 2013?
Offer a terse response. 6.67. What is the difference between the Rating of statistical capacity (0-100) of Periodicity assessment in 2011 and the Rating of statistical capacity (0-100) of Source data assessment in 2013?
Your answer should be very brief. 10. What is the difference between the Rating of statistical capacity (0-100) of Methodology assessment in 2011 and the Rating of statistical capacity (0-100) of Overall level in 2014?
Provide a succinct answer. -6.67. What is the difference between the Rating of statistical capacity (0-100) of Methodology assessment in 2011 and the Rating of statistical capacity (0-100) of Periodicity assessment in 2014?
Your answer should be compact. -10. What is the difference between the Rating of statistical capacity (0-100) in Methodology assessment in 2011 and the Rating of statistical capacity (0-100) in Source data assessment in 2014?
Provide a short and direct response. 0. What is the difference between the Rating of statistical capacity (0-100) in Overall level in 2011 and the Rating of statistical capacity (0-100) in Periodicity assessment in 2014?
Give a very brief answer. -3.33. What is the difference between the Rating of statistical capacity (0-100) in Overall level in 2011 and the Rating of statistical capacity (0-100) in Source data assessment in 2014?
Make the answer very short. 6.67. What is the difference between the Rating of statistical capacity (0-100) of Methodology assessment in 2012 and the Rating of statistical capacity (0-100) of Overall level in 2013?
Offer a terse response. 1.11. What is the difference between the Rating of statistical capacity (0-100) in Methodology assessment in 2012 and the Rating of statistical capacity (0-100) in Periodicity assessment in 2013?
Give a very brief answer. -6.67. What is the difference between the Rating of statistical capacity (0-100) of Methodology assessment in 2012 and the Rating of statistical capacity (0-100) of Source data assessment in 2013?
Provide a succinct answer. 10. What is the difference between the Rating of statistical capacity (0-100) of Overall level in 2012 and the Rating of statistical capacity (0-100) of Periodicity assessment in 2013?
Offer a very short reply. -5.56. What is the difference between the Rating of statistical capacity (0-100) of Overall level in 2012 and the Rating of statistical capacity (0-100) of Source data assessment in 2013?
Keep it short and to the point. 11.11. What is the difference between the Rating of statistical capacity (0-100) in Periodicity assessment in 2012 and the Rating of statistical capacity (0-100) in Source data assessment in 2013?
Your answer should be very brief. 13.33. What is the difference between the Rating of statistical capacity (0-100) of Methodology assessment in 2012 and the Rating of statistical capacity (0-100) of Periodicity assessment in 2014?
Offer a terse response. 0. What is the difference between the Rating of statistical capacity (0-100) of Overall level in 2012 and the Rating of statistical capacity (0-100) of Periodicity assessment in 2014?
Provide a succinct answer. 1.11. What is the difference between the Rating of statistical capacity (0-100) of Overall level in 2012 and the Rating of statistical capacity (0-100) of Source data assessment in 2014?
Your response must be concise. 11.11. What is the difference between the Rating of statistical capacity (0-100) in Periodicity assessment in 2012 and the Rating of statistical capacity (0-100) in Source data assessment in 2014?
Provide a succinct answer. 13.33. What is the difference between the Rating of statistical capacity (0-100) in Methodology assessment in 2013 and the Rating of statistical capacity (0-100) in Overall level in 2014?
Make the answer very short. 3.33. What is the difference between the Rating of statistical capacity (0-100) of Methodology assessment in 2013 and the Rating of statistical capacity (0-100) of Source data assessment in 2014?
Make the answer very short. 10. What is the difference between the Rating of statistical capacity (0-100) of Overall level in 2013 and the Rating of statistical capacity (0-100) of Periodicity assessment in 2014?
Provide a short and direct response. -1.11. What is the difference between the Rating of statistical capacity (0-100) of Overall level in 2013 and the Rating of statistical capacity (0-100) of Source data assessment in 2014?
Provide a short and direct response. 8.89. What is the difference between the Rating of statistical capacity (0-100) in Periodicity assessment in 2013 and the Rating of statistical capacity (0-100) in Source data assessment in 2014?
Offer a very short reply. 16.67. What is the average Rating of statistical capacity (0-100) in Methodology assessment per year?
Provide a short and direct response. 63.33. What is the average Rating of statistical capacity (0-100) in Overall level per year?
Your answer should be very brief. 67.16. What is the average Rating of statistical capacity (0-100) of Periodicity assessment per year?
Keep it short and to the point. 73.7. What is the average Rating of statistical capacity (0-100) of Source data assessment per year?
Make the answer very short. 64.44. In the year 2006, what is the difference between the Rating of statistical capacity (0-100) of Methodology assessment and Rating of statistical capacity (0-100) of Overall level?
Give a very brief answer. -1.11. In the year 2006, what is the difference between the Rating of statistical capacity (0-100) in Methodology assessment and Rating of statistical capacity (0-100) in Source data assessment?
Keep it short and to the point. 0. In the year 2006, what is the difference between the Rating of statistical capacity (0-100) of Overall level and Rating of statistical capacity (0-100) of Periodicity assessment?
Give a very brief answer. -2.22. In the year 2007, what is the difference between the Rating of statistical capacity (0-100) in Methodology assessment and Rating of statistical capacity (0-100) in Overall level?
Provide a succinct answer. -14.44. In the year 2007, what is the difference between the Rating of statistical capacity (0-100) in Methodology assessment and Rating of statistical capacity (0-100) in Periodicity assessment?
Provide a short and direct response. -23.33. In the year 2007, what is the difference between the Rating of statistical capacity (0-100) in Methodology assessment and Rating of statistical capacity (0-100) in Source data assessment?
Your answer should be compact. -20. In the year 2007, what is the difference between the Rating of statistical capacity (0-100) of Overall level and Rating of statistical capacity (0-100) of Periodicity assessment?
Your answer should be very brief. -8.89. In the year 2007, what is the difference between the Rating of statistical capacity (0-100) in Overall level and Rating of statistical capacity (0-100) in Source data assessment?
Provide a short and direct response. -5.56. In the year 2007, what is the difference between the Rating of statistical capacity (0-100) in Periodicity assessment and Rating of statistical capacity (0-100) in Source data assessment?
Keep it short and to the point. 3.33. In the year 2008, what is the difference between the Rating of statistical capacity (0-100) in Methodology assessment and Rating of statistical capacity (0-100) in Overall level?
Ensure brevity in your answer.  -8.89. In the year 2008, what is the difference between the Rating of statistical capacity (0-100) of Methodology assessment and Rating of statistical capacity (0-100) of Periodicity assessment?
Your response must be concise. -16.67. In the year 2008, what is the difference between the Rating of statistical capacity (0-100) of Overall level and Rating of statistical capacity (0-100) of Periodicity assessment?
Offer a very short reply. -7.78. In the year 2008, what is the difference between the Rating of statistical capacity (0-100) of Overall level and Rating of statistical capacity (0-100) of Source data assessment?
Your answer should be very brief. -1.11. In the year 2009, what is the difference between the Rating of statistical capacity (0-100) of Methodology assessment and Rating of statistical capacity (0-100) of Overall level?
Your response must be concise. -1.11. In the year 2009, what is the difference between the Rating of statistical capacity (0-100) in Methodology assessment and Rating of statistical capacity (0-100) in Periodicity assessment?
Ensure brevity in your answer.  -13.33. In the year 2009, what is the difference between the Rating of statistical capacity (0-100) of Methodology assessment and Rating of statistical capacity (0-100) of Source data assessment?
Make the answer very short. 10. In the year 2009, what is the difference between the Rating of statistical capacity (0-100) in Overall level and Rating of statistical capacity (0-100) in Periodicity assessment?
Give a very brief answer. -12.22. In the year 2009, what is the difference between the Rating of statistical capacity (0-100) in Overall level and Rating of statistical capacity (0-100) in Source data assessment?
Make the answer very short. 11.11. In the year 2009, what is the difference between the Rating of statistical capacity (0-100) of Periodicity assessment and Rating of statistical capacity (0-100) of Source data assessment?
Provide a succinct answer. 23.33. In the year 2010, what is the difference between the Rating of statistical capacity (0-100) in Methodology assessment and Rating of statistical capacity (0-100) in Overall level?
Make the answer very short. -5.56. In the year 2010, what is the difference between the Rating of statistical capacity (0-100) in Methodology assessment and Rating of statistical capacity (0-100) in Periodicity assessment?
Give a very brief answer. -16.67. In the year 2010, what is the difference between the Rating of statistical capacity (0-100) in Methodology assessment and Rating of statistical capacity (0-100) in Source data assessment?
Give a very brief answer. 0. In the year 2010, what is the difference between the Rating of statistical capacity (0-100) in Overall level and Rating of statistical capacity (0-100) in Periodicity assessment?
Offer a terse response. -11.11. In the year 2010, what is the difference between the Rating of statistical capacity (0-100) in Overall level and Rating of statistical capacity (0-100) in Source data assessment?
Your response must be concise. 5.56. In the year 2010, what is the difference between the Rating of statistical capacity (0-100) of Periodicity assessment and Rating of statistical capacity (0-100) of Source data assessment?
Ensure brevity in your answer.  16.67. In the year 2011, what is the difference between the Rating of statistical capacity (0-100) in Methodology assessment and Rating of statistical capacity (0-100) in Overall level?
Make the answer very short. -6.67. In the year 2011, what is the difference between the Rating of statistical capacity (0-100) in Methodology assessment and Rating of statistical capacity (0-100) in Periodicity assessment?
Your answer should be compact. -10. In the year 2011, what is the difference between the Rating of statistical capacity (0-100) in Overall level and Rating of statistical capacity (0-100) in Periodicity assessment?
Ensure brevity in your answer.  -3.33. In the year 2011, what is the difference between the Rating of statistical capacity (0-100) of Overall level and Rating of statistical capacity (0-100) of Source data assessment?
Your answer should be very brief. -3.33. In the year 2012, what is the difference between the Rating of statistical capacity (0-100) in Methodology assessment and Rating of statistical capacity (0-100) in Overall level?
Make the answer very short. -1.11. In the year 2012, what is the difference between the Rating of statistical capacity (0-100) in Overall level and Rating of statistical capacity (0-100) in Periodicity assessment?
Your response must be concise. -2.22. In the year 2012, what is the difference between the Rating of statistical capacity (0-100) of Periodicity assessment and Rating of statistical capacity (0-100) of Source data assessment?
Your answer should be very brief. 3.33. In the year 2013, what is the difference between the Rating of statistical capacity (0-100) in Methodology assessment and Rating of statistical capacity (0-100) in Periodicity assessment?
Provide a succinct answer. -6.67. In the year 2013, what is the difference between the Rating of statistical capacity (0-100) in Overall level and Rating of statistical capacity (0-100) in Periodicity assessment?
Your response must be concise. -7.78. In the year 2013, what is the difference between the Rating of statistical capacity (0-100) of Overall level and Rating of statistical capacity (0-100) of Source data assessment?
Make the answer very short. 8.89. In the year 2013, what is the difference between the Rating of statistical capacity (0-100) in Periodicity assessment and Rating of statistical capacity (0-100) in Source data assessment?
Offer a very short reply. 16.67. In the year 2014, what is the difference between the Rating of statistical capacity (0-100) in Methodology assessment and Rating of statistical capacity (0-100) in Overall level?
Your answer should be compact. 3.33. In the year 2014, what is the difference between the Rating of statistical capacity (0-100) of Methodology assessment and Rating of statistical capacity (0-100) of Periodicity assessment?
Offer a terse response. 0. What is the ratio of the Rating of statistical capacity (0-100) in Methodology assessment in 2006 to that in 2007?
Your answer should be compact. 1.4. What is the ratio of the Rating of statistical capacity (0-100) of Overall level in 2006 to that in 2007?
Your response must be concise. 1.1. What is the ratio of the Rating of statistical capacity (0-100) in Overall level in 2006 to that in 2008?
Offer a terse response. 1.03. What is the ratio of the Rating of statistical capacity (0-100) of Periodicity assessment in 2006 to that in 2008?
Offer a very short reply. 0.96. What is the ratio of the Rating of statistical capacity (0-100) in Overall level in 2006 to that in 2009?
Your answer should be very brief. 1.16. What is the ratio of the Rating of statistical capacity (0-100) in Periodicity assessment in 2006 to that in 2009?
Provide a short and direct response. 1. What is the ratio of the Rating of statistical capacity (0-100) of Source data assessment in 2006 to that in 2009?
Keep it short and to the point. 1.4. What is the ratio of the Rating of statistical capacity (0-100) of Overall level in 2006 to that in 2010?
Keep it short and to the point. 1.08. What is the ratio of the Rating of statistical capacity (0-100) of Periodicity assessment in 2006 to that in 2010?
Give a very brief answer. 0.96. What is the ratio of the Rating of statistical capacity (0-100) in Source data assessment in 2006 to that in 2010?
Provide a short and direct response. 1.17. What is the ratio of the Rating of statistical capacity (0-100) of Methodology assessment in 2006 to that in 2011?
Provide a succinct answer. 1.17. What is the ratio of the Rating of statistical capacity (0-100) in Overall level in 2006 to that in 2011?
Provide a short and direct response. 1.07. What is the ratio of the Rating of statistical capacity (0-100) in Periodicity assessment in 2006 to that in 2011?
Make the answer very short. 1.05. What is the ratio of the Rating of statistical capacity (0-100) in Source data assessment in 2006 to that in 2011?
Your answer should be very brief. 1. What is the ratio of the Rating of statistical capacity (0-100) in Methodology assessment in 2006 to that in 2012?
Offer a terse response. 1. What is the ratio of the Rating of statistical capacity (0-100) in Overall level in 2006 to that in 2012?
Offer a terse response. 1. What is the ratio of the Rating of statistical capacity (0-100) in Periodicity assessment in 2006 to that in 2012?
Your answer should be very brief. 1. What is the ratio of the Rating of statistical capacity (0-100) of Source data assessment in 2006 to that in 2012?
Keep it short and to the point. 1. What is the ratio of the Rating of statistical capacity (0-100) of Overall level in 2006 to that in 2013?
Your answer should be very brief. 1.03. What is the ratio of the Rating of statistical capacity (0-100) of Periodicity assessment in 2006 to that in 2013?
Provide a short and direct response. 0.96. What is the ratio of the Rating of statistical capacity (0-100) of Overall level in 2006 to that in 2014?
Offer a terse response. 1.07. What is the ratio of the Rating of statistical capacity (0-100) of Periodicity assessment in 2006 to that in 2014?
Ensure brevity in your answer.  1.05. What is the ratio of the Rating of statistical capacity (0-100) in Source data assessment in 2006 to that in 2014?
Give a very brief answer. 1.17. What is the ratio of the Rating of statistical capacity (0-100) in Overall level in 2007 to that in 2008?
Ensure brevity in your answer.  0.94. What is the ratio of the Rating of statistical capacity (0-100) of Periodicity assessment in 2007 to that in 2008?
Ensure brevity in your answer.  0.96. What is the ratio of the Rating of statistical capacity (0-100) in Source data assessment in 2007 to that in 2008?
Give a very brief answer. 1. What is the ratio of the Rating of statistical capacity (0-100) in Methodology assessment in 2007 to that in 2009?
Give a very brief answer. 0.83. What is the ratio of the Rating of statistical capacity (0-100) in Overall level in 2007 to that in 2009?
Provide a short and direct response. 1.05. What is the ratio of the Rating of statistical capacity (0-100) of Periodicity assessment in 2007 to that in 2009?
Ensure brevity in your answer.  1. What is the ratio of the Rating of statistical capacity (0-100) of Source data assessment in 2007 to that in 2009?
Provide a short and direct response. 1.4. What is the ratio of the Rating of statistical capacity (0-100) in Overall level in 2007 to that in 2010?
Ensure brevity in your answer.  0.98. What is the ratio of the Rating of statistical capacity (0-100) in Periodicity assessment in 2007 to that in 2010?
Keep it short and to the point. 0.96. What is the ratio of the Rating of statistical capacity (0-100) in Source data assessment in 2007 to that in 2010?
Provide a succinct answer. 1.17. What is the ratio of the Rating of statistical capacity (0-100) in Overall level in 2007 to that in 2011?
Your answer should be very brief. 0.97. What is the ratio of the Rating of statistical capacity (0-100) of Periodicity assessment in 2007 to that in 2011?
Your answer should be very brief. 1.05. What is the ratio of the Rating of statistical capacity (0-100) in Source data assessment in 2007 to that in 2011?
Offer a terse response. 1. What is the ratio of the Rating of statistical capacity (0-100) of Methodology assessment in 2007 to that in 2012?
Give a very brief answer. 0.71. What is the ratio of the Rating of statistical capacity (0-100) of Overall level in 2007 to that in 2012?
Make the answer very short. 0.91. What is the ratio of the Rating of statistical capacity (0-100) of Overall level in 2007 to that in 2013?
Provide a short and direct response. 0.94. What is the ratio of the Rating of statistical capacity (0-100) of Periodicity assessment in 2007 to that in 2013?
Keep it short and to the point. 0.96. What is the ratio of the Rating of statistical capacity (0-100) in Overall level in 2007 to that in 2014?
Give a very brief answer. 0.97. What is the ratio of the Rating of statistical capacity (0-100) of Periodicity assessment in 2007 to that in 2014?
Your answer should be compact. 1.05. What is the ratio of the Rating of statistical capacity (0-100) in Methodology assessment in 2008 to that in 2009?
Give a very brief answer. 1. What is the ratio of the Rating of statistical capacity (0-100) of Overall level in 2008 to that in 2009?
Provide a short and direct response. 1.13. What is the ratio of the Rating of statistical capacity (0-100) in Periodicity assessment in 2008 to that in 2009?
Provide a short and direct response. 1.05. What is the ratio of the Rating of statistical capacity (0-100) in Overall level in 2008 to that in 2010?
Provide a succinct answer. 1.05. What is the ratio of the Rating of statistical capacity (0-100) of Periodicity assessment in 2008 to that in 2010?
Keep it short and to the point. 1. What is the ratio of the Rating of statistical capacity (0-100) in Source data assessment in 2008 to that in 2010?
Your response must be concise. 1.17. What is the ratio of the Rating of statistical capacity (0-100) of Periodicity assessment in 2008 to that in 2011?
Make the answer very short. 1.1. What is the ratio of the Rating of statistical capacity (0-100) in Source data assessment in 2008 to that in 2011?
Provide a succinct answer. 1. What is the ratio of the Rating of statistical capacity (0-100) of Methodology assessment in 2008 to that in 2012?
Ensure brevity in your answer.  0.86. What is the ratio of the Rating of statistical capacity (0-100) of Overall level in 2008 to that in 2012?
Your answer should be compact. 0.97. What is the ratio of the Rating of statistical capacity (0-100) in Periodicity assessment in 2008 to that in 2012?
Your answer should be very brief. 1.05. What is the ratio of the Rating of statistical capacity (0-100) in Source data assessment in 2008 to that in 2012?
Offer a very short reply. 1. What is the ratio of the Rating of statistical capacity (0-100) in Overall level in 2008 to that in 2014?
Provide a short and direct response. 1.03. What is the ratio of the Rating of statistical capacity (0-100) of Periodicity assessment in 2008 to that in 2014?
Your answer should be very brief. 1.1. What is the ratio of the Rating of statistical capacity (0-100) in Methodology assessment in 2009 to that in 2010?
Provide a succinct answer. 1. What is the ratio of the Rating of statistical capacity (0-100) in Overall level in 2009 to that in 2010?
Ensure brevity in your answer.  0.93. What is the ratio of the Rating of statistical capacity (0-100) of Periodicity assessment in 2009 to that in 2010?
Offer a very short reply. 0.96. What is the ratio of the Rating of statistical capacity (0-100) in Periodicity assessment in 2009 to that in 2011?
Your response must be concise. 1.05. What is the ratio of the Rating of statistical capacity (0-100) in Source data assessment in 2009 to that in 2011?
Provide a short and direct response. 0.71. What is the ratio of the Rating of statistical capacity (0-100) of Methodology assessment in 2009 to that in 2012?
Keep it short and to the point. 0.86. What is the ratio of the Rating of statistical capacity (0-100) in Overall level in 2009 to that in 2012?
Your response must be concise. 0.86. What is the ratio of the Rating of statistical capacity (0-100) of Periodicity assessment in 2009 to that in 2012?
Provide a short and direct response. 1. What is the ratio of the Rating of statistical capacity (0-100) of Source data assessment in 2009 to that in 2012?
Offer a terse response. 0.71. What is the ratio of the Rating of statistical capacity (0-100) of Methodology assessment in 2009 to that in 2013?
Ensure brevity in your answer.  0.86. What is the ratio of the Rating of statistical capacity (0-100) in Overall level in 2009 to that in 2013?
Offer a terse response. 0.89. What is the ratio of the Rating of statistical capacity (0-100) of Periodicity assessment in 2009 to that in 2013?
Provide a short and direct response. 0.96. What is the ratio of the Rating of statistical capacity (0-100) of Methodology assessment in 2009 to that in 2014?
Provide a short and direct response. 0.86. What is the ratio of the Rating of statistical capacity (0-100) of Periodicity assessment in 2009 to that in 2014?
Your answer should be very brief. 1.05. What is the ratio of the Rating of statistical capacity (0-100) in Methodology assessment in 2010 to that in 2011?
Make the answer very short. 1. What is the ratio of the Rating of statistical capacity (0-100) in Overall level in 2010 to that in 2011?
Make the answer very short. 0.98. What is the ratio of the Rating of statistical capacity (0-100) in Periodicity assessment in 2010 to that in 2011?
Provide a short and direct response. 1.1. What is the ratio of the Rating of statistical capacity (0-100) of Methodology assessment in 2010 to that in 2012?
Offer a terse response. 0.86. What is the ratio of the Rating of statistical capacity (0-100) of Overall level in 2010 to that in 2012?
Ensure brevity in your answer.  0.92. What is the ratio of the Rating of statistical capacity (0-100) of Periodicity assessment in 2010 to that in 2012?
Your answer should be compact. 1.05. What is the ratio of the Rating of statistical capacity (0-100) of Source data assessment in 2010 to that in 2012?
Your answer should be compact. 0.86. What is the ratio of the Rating of statistical capacity (0-100) in Methodology assessment in 2010 to that in 2013?
Provide a short and direct response. 0.86. What is the ratio of the Rating of statistical capacity (0-100) of Overall level in 2010 to that in 2013?
Offer a very short reply. 0.95. What is the ratio of the Rating of statistical capacity (0-100) in Periodicity assessment in 2010 to that in 2013?
Offer a very short reply. 1. What is the ratio of the Rating of statistical capacity (0-100) in Source data assessment in 2010 to that in 2013?
Provide a short and direct response. 1. What is the ratio of the Rating of statistical capacity (0-100) of Overall level in 2010 to that in 2014?
Your response must be concise. 0.98. What is the ratio of the Rating of statistical capacity (0-100) of Periodicity assessment in 2010 to that in 2014?
Your answer should be compact. 1.1. What is the ratio of the Rating of statistical capacity (0-100) in Methodology assessment in 2011 to that in 2012?
Keep it short and to the point. 0.86. What is the ratio of the Rating of statistical capacity (0-100) of Periodicity assessment in 2011 to that in 2012?
Provide a short and direct response. 0.95. What is the ratio of the Rating of statistical capacity (0-100) of Source data assessment in 2011 to that in 2012?
Your response must be concise. 1. What is the ratio of the Rating of statistical capacity (0-100) of Methodology assessment in 2011 to that in 2013?
Your response must be concise. 0.86. What is the ratio of the Rating of statistical capacity (0-100) of Periodicity assessment in 2011 to that in 2013?
Provide a succinct answer. 0.91. What is the ratio of the Rating of statistical capacity (0-100) in Overall level in 2011 to that in 2014?
Keep it short and to the point. 1. What is the ratio of the Rating of statistical capacity (0-100) in Source data assessment in 2011 to that in 2014?
Give a very brief answer. 1.17. What is the ratio of the Rating of statistical capacity (0-100) in Overall level in 2012 to that in 2013?
Provide a short and direct response. 1.03. What is the ratio of the Rating of statistical capacity (0-100) of Periodicity assessment in 2012 to that in 2013?
Give a very brief answer. 0.96. What is the ratio of the Rating of statistical capacity (0-100) in Methodology assessment in 2012 to that in 2014?
Ensure brevity in your answer.  1. What is the ratio of the Rating of statistical capacity (0-100) of Overall level in 2012 to that in 2014?
Provide a succinct answer. 1.07. What is the ratio of the Rating of statistical capacity (0-100) of Periodicity assessment in 2012 to that in 2014?
Provide a succinct answer. 1.05. What is the ratio of the Rating of statistical capacity (0-100) of Methodology assessment in 2013 to that in 2014?
Provide a short and direct response. 1. What is the ratio of the Rating of statistical capacity (0-100) in Periodicity assessment in 2013 to that in 2014?
Your response must be concise. 1.1. What is the ratio of the Rating of statistical capacity (0-100) of Source data assessment in 2013 to that in 2014?
Keep it short and to the point. 1. What is the difference between the highest and the second highest Rating of statistical capacity (0-100) of Methodology assessment?
Offer a terse response. 0. What is the difference between the highest and the lowest Rating of statistical capacity (0-100) of Methodology assessment?
Keep it short and to the point. 20. What is the difference between the highest and the lowest Rating of statistical capacity (0-100) in Source data assessment?
Make the answer very short. 20. 